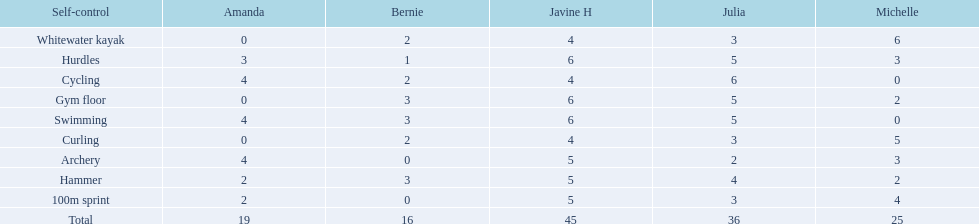What is the average score on 100m sprint? 2.8. 